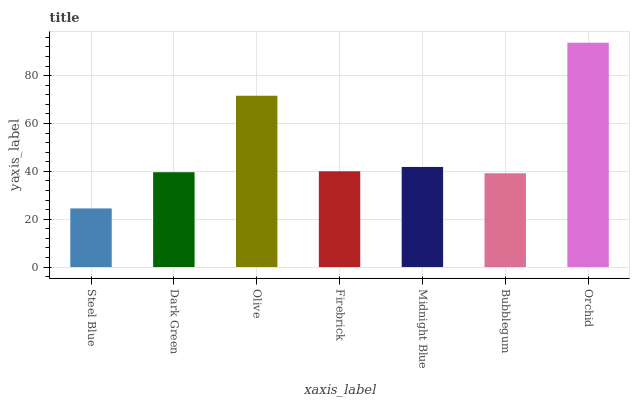Is Steel Blue the minimum?
Answer yes or no. Yes. Is Orchid the maximum?
Answer yes or no. Yes. Is Dark Green the minimum?
Answer yes or no. No. Is Dark Green the maximum?
Answer yes or no. No. Is Dark Green greater than Steel Blue?
Answer yes or no. Yes. Is Steel Blue less than Dark Green?
Answer yes or no. Yes. Is Steel Blue greater than Dark Green?
Answer yes or no. No. Is Dark Green less than Steel Blue?
Answer yes or no. No. Is Firebrick the high median?
Answer yes or no. Yes. Is Firebrick the low median?
Answer yes or no. Yes. Is Bubblegum the high median?
Answer yes or no. No. Is Orchid the low median?
Answer yes or no. No. 